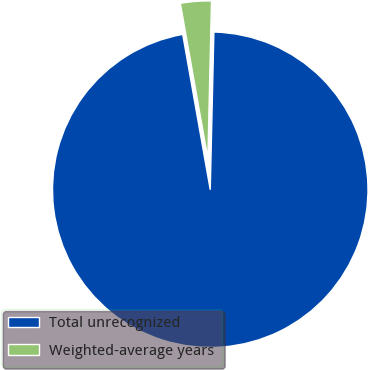Convert chart. <chart><loc_0><loc_0><loc_500><loc_500><pie_chart><fcel>Total unrecognized<fcel>Weighted-average years<nl><fcel>96.84%<fcel>3.16%<nl></chart> 